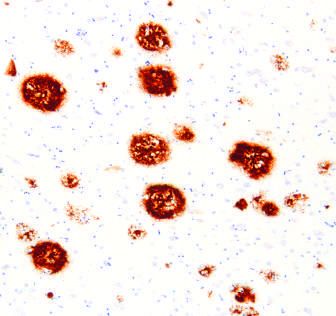what is present in the core of the plaques as well as in the surrounding region?
Answer the question using a single word or phrase. Peptide 